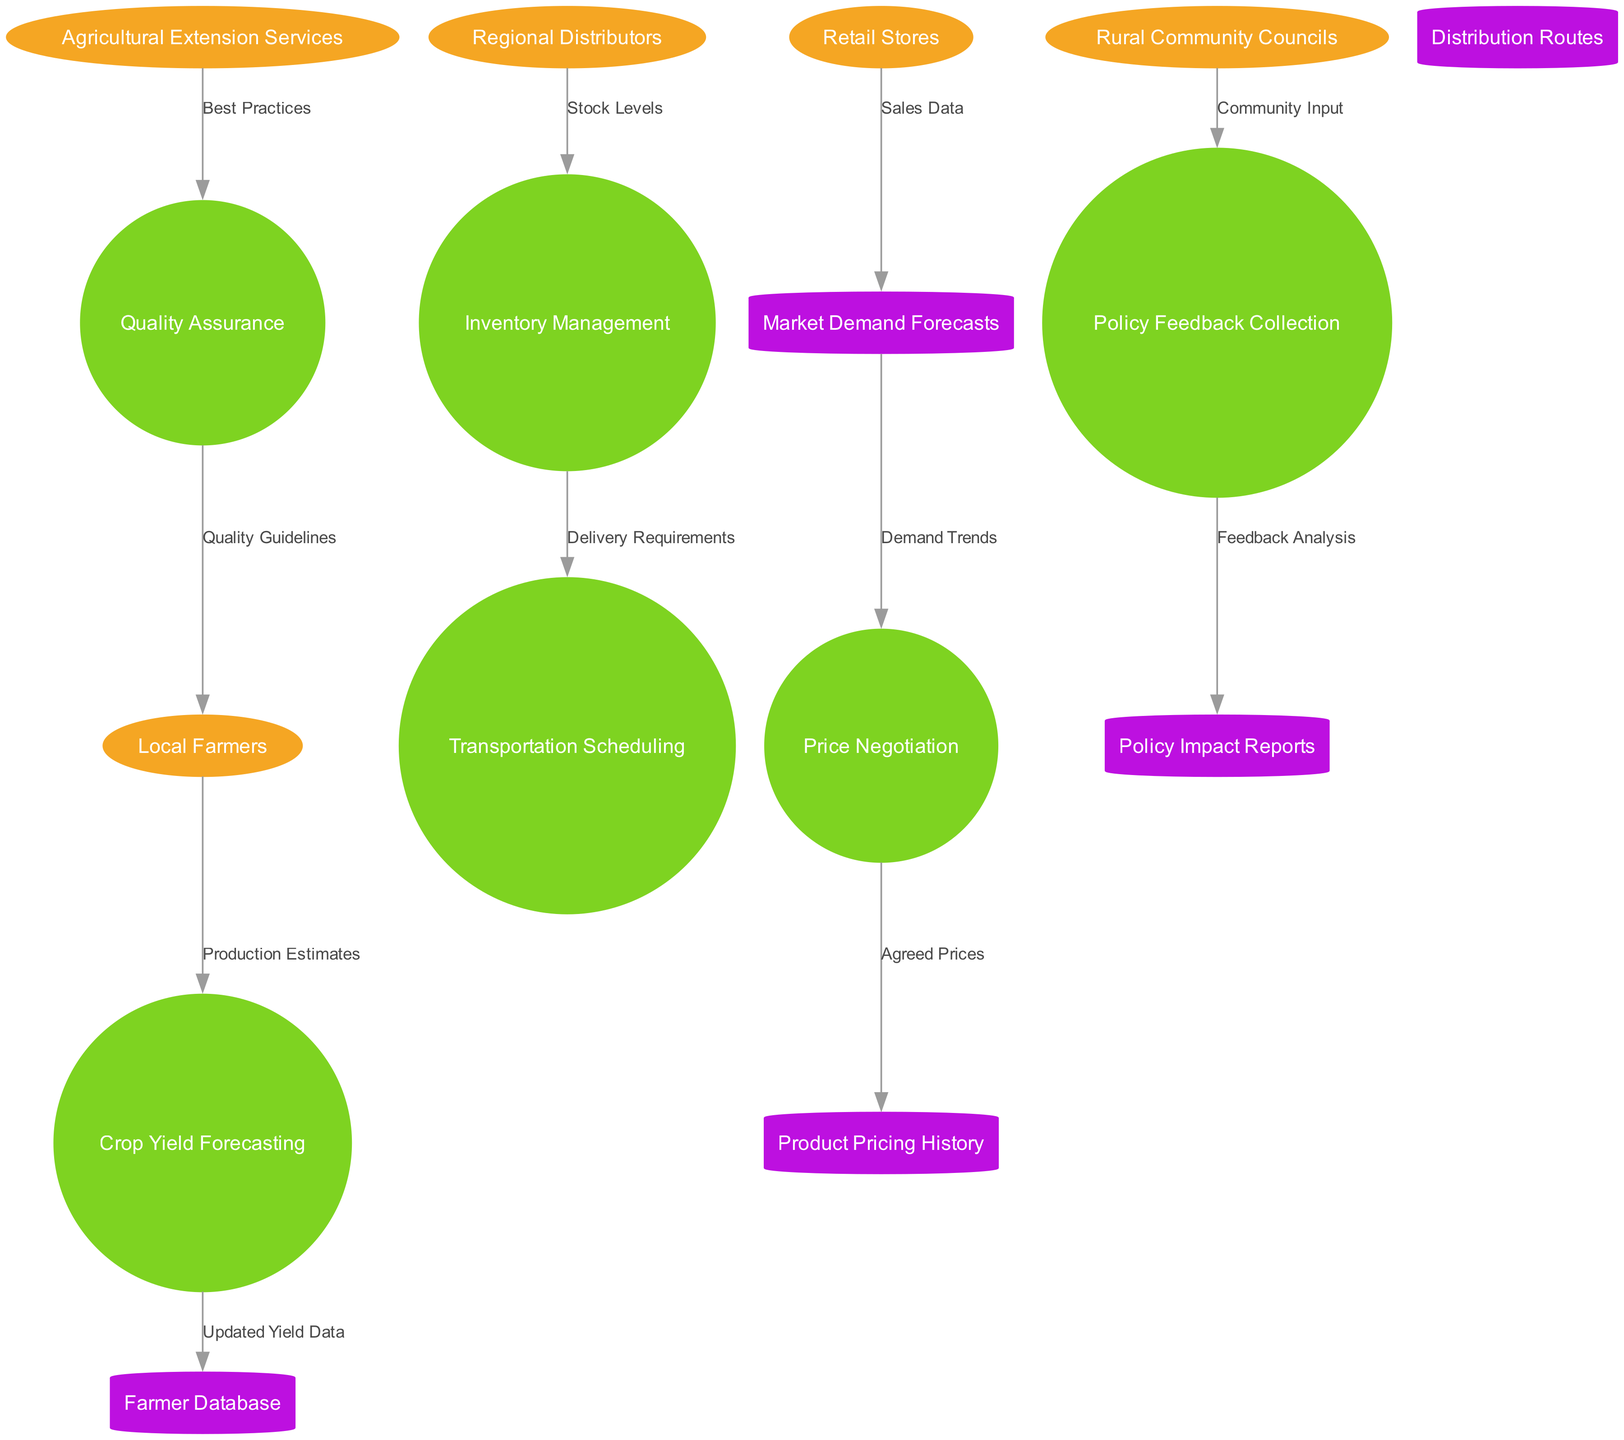What is the total number of external entities in the diagram? The diagram lists five external entities: Local Farmers, Regional Distributors, Retail Stores, Agricultural Extension Services, and Rural Community Councils. Counting these gives us a total of five.
Answer: 5 What data flows from Local Farmers to Crop Yield Forecasting? The diagram specifies a data flow labeled "Production Estimates" that goes from Local Farmers to Crop Yield Forecasting. This establishes the connection and specific data exchanged between these two nodes.
Answer: Production Estimates Which process receives "Sales Data" as input? The flow chart indicates that Sales Data is sent from Retail Stores to Market Demand Forecasts. Therefore, Market Demand Forecasts is the process that receives this specific input.
Answer: Market Demand Forecasts How many data stores are present in the diagram? In the diagram, there are five data stores: Farmer Database, Market Demand Forecasts, Product Pricing History, Distribution Routes, and Policy Impact Reports. This means the total number of data stores is five.
Answer: 5 What is the relationship between Quality Assurance and Local Farmers? The diagram shows a flow from Quality Assurance to Local Farmers that is labeled "Quality Guidelines." This indicates that Local Farmers receive quality guidelines as a result of the quality assurance process.
Answer: Quality Guidelines What kind of input does Policy Feedback Collection receive? The diagram shows that Policy Feedback Collection receives "Community Input" from Rural Community Councils, which highlights the importance of community feedback in the policy-making process.
Answer: Community Input Which process is responsible for managing stock levels? According to the diagram, Regional Distributors send "Stock Levels" to the Inventory Management process, meaning that Inventory Management is responsible for managing these stock levels.
Answer: Inventory Management What feedback does Policy Feedback Collection generate? The diagram indicates that Policy Feedback Collection produces "Feedback Analysis," as shown in the flow directed towards Policy Impact Reports. This means the outcome of this collection process is feedback analysis.
Answer: Feedback Analysis What best practices are sent to the Quality Assurance process? The diagram specifies that "Best Practices" flow from Agricultural Extension Services to the Quality Assurance process, making clear the direction and type of information provided.
Answer: Best Practices 